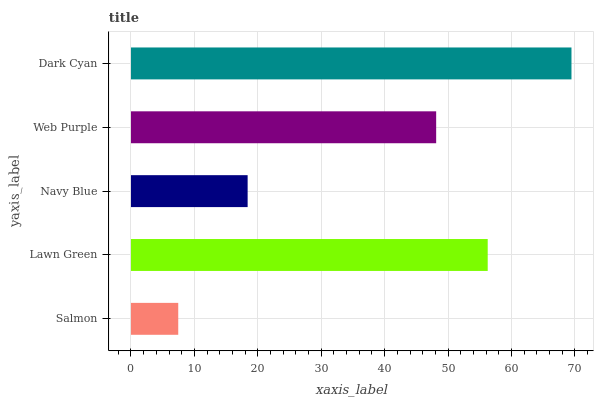Is Salmon the minimum?
Answer yes or no. Yes. Is Dark Cyan the maximum?
Answer yes or no. Yes. Is Lawn Green the minimum?
Answer yes or no. No. Is Lawn Green the maximum?
Answer yes or no. No. Is Lawn Green greater than Salmon?
Answer yes or no. Yes. Is Salmon less than Lawn Green?
Answer yes or no. Yes. Is Salmon greater than Lawn Green?
Answer yes or no. No. Is Lawn Green less than Salmon?
Answer yes or no. No. Is Web Purple the high median?
Answer yes or no. Yes. Is Web Purple the low median?
Answer yes or no. Yes. Is Dark Cyan the high median?
Answer yes or no. No. Is Dark Cyan the low median?
Answer yes or no. No. 